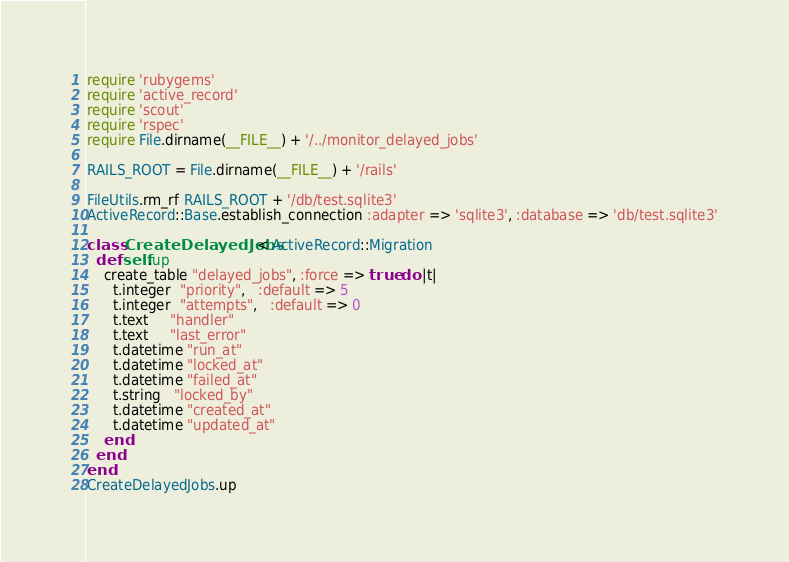<code> <loc_0><loc_0><loc_500><loc_500><_Ruby_>require 'rubygems'
require 'active_record'
require 'scout'
require 'rspec'
require File.dirname(__FILE__) + '/../monitor_delayed_jobs'

RAILS_ROOT = File.dirname(__FILE__) + '/rails'

FileUtils.rm_rf RAILS_ROOT + '/db/test.sqlite3'
ActiveRecord::Base.establish_connection :adapter => 'sqlite3', :database => 'db/test.sqlite3'

class CreateDelayedJobs < ActiveRecord::Migration
  def self.up
    create_table "delayed_jobs", :force => true do |t|
      t.integer  "priority",   :default => 5
      t.integer  "attempts",   :default => 0
      t.text     "handler"
      t.text     "last_error"
      t.datetime "run_at"
      t.datetime "locked_at"
      t.datetime "failed_at"
      t.string   "locked_by"
      t.datetime "created_at"
      t.datetime "updated_at"
    end
  end
end
CreateDelayedJobs.up</code> 